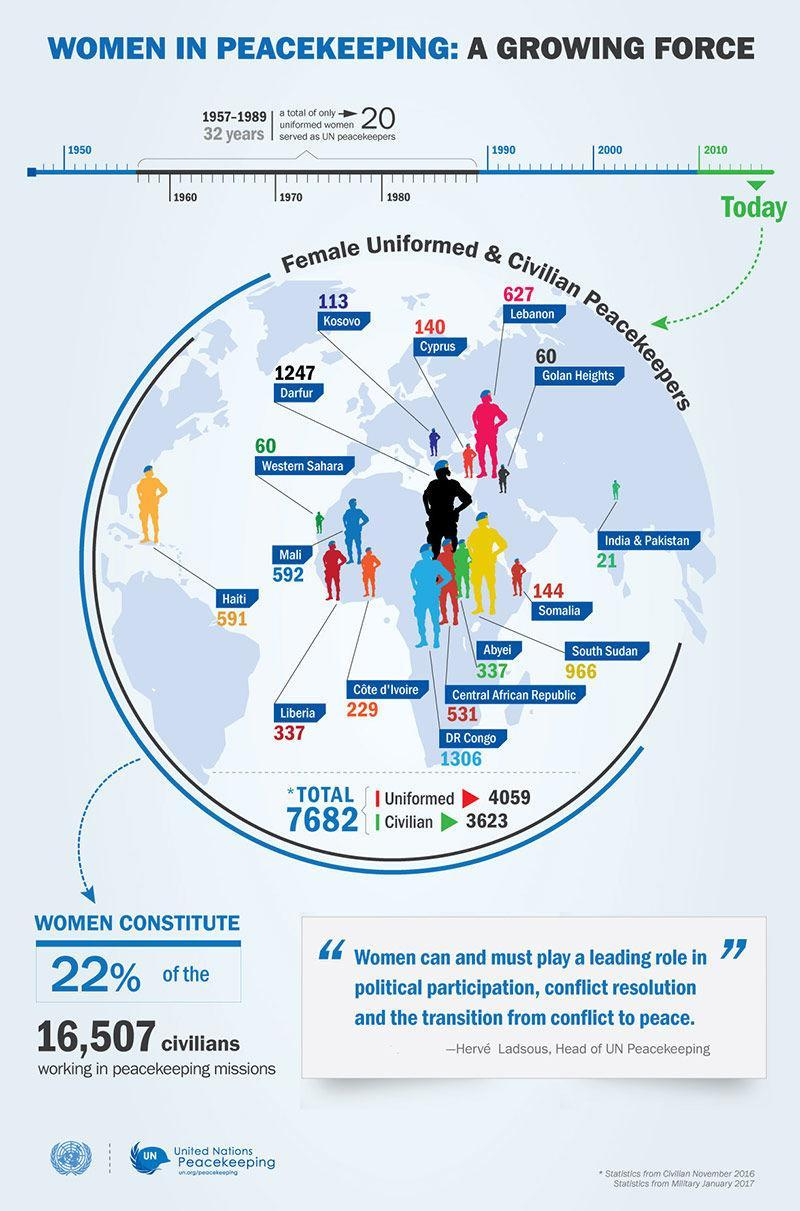How many female civilians served as UN peacekeepers in India & Pakistan in 2016?
Answer the question with a short phrase. 21 How many uniformed women served as UN peacekeepers in Lebanon in 2016? 627 How many uniformed women served as UN peacekeepers during 1957-1989? 20 How many uniformed women served as UN peacekeepers in Somalia in 2016? 144 What percentage of civilians working in the UN peacekeeping missions are women? 22% How many female civilians served as UN peacekeepers in Western Sahara in 2016? 60 